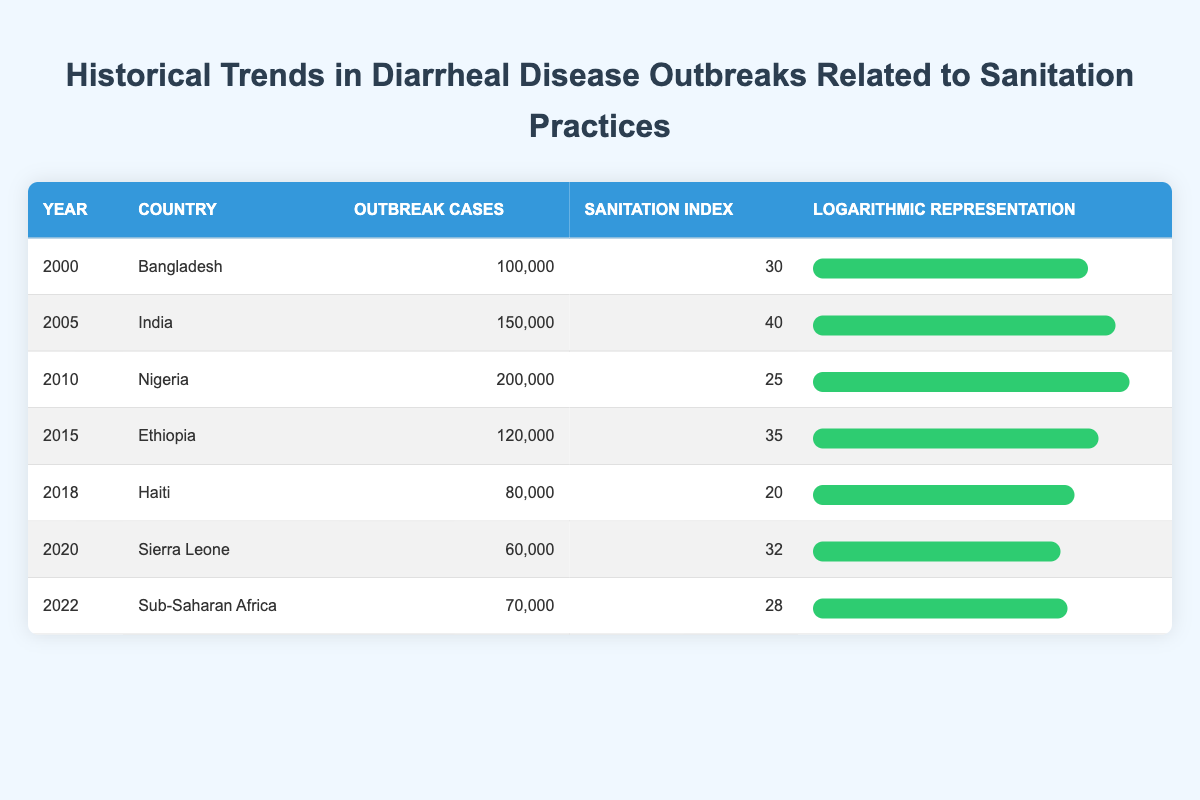What year had the highest number of outbreak cases? By looking at the "Outbreak Cases" column, I can determine the maximum value, which is 200,000 cases in the year 2010 for Nigeria.
Answer: 2010 What is the sanitation index for Ethiopia in 2015? The sanitation index for Ethiopia, listed in the table for the year 2015, is 35.
Answer: 35 Which country had a sanitation index of 40? Referring to the "Sanitation Index" column, I find that India had a sanitation index of 40 in the year 2005.
Answer: India Are there any years in the table where outbreak cases exceeded 100,000? I checked the "Outbreak Cases" column for values greater than 100,000. The years 2000, 2005, and 2010 exceed this threshold, confirming that yes, there are multiple years with outbreak cases above 100,000.
Answer: Yes What is the average number of outbreak cases across all listed years? To find the average, I sum all outbreak cases (100000 + 150000 + 200000 + 120000 + 80000 + 60000 + 70000 = 820000) and divide by the number of years, which is 7 (820000/7 = 117142.86). Rounding off, the average number of outbreak cases is approximately 117143.
Answer: 117143 Which country had the lowest sanitation index, and what was that index? The lowest sanitation index in the table is found under Haiti in 2018, which is 20. Thus, the country with the lowest sanitation index is Haiti.
Answer: Haiti, 20 Is it true that the number of outbreak cases decreased from 2010 to 2020? Comparing the outbreak cases from Nigeria in 2010 (200,000) and Sierra Leone in 2020 (60,000), there is a clear decrease in outbreak cases over this time period, confirming that this statement is true.
Answer: True If the sanitation index improved to 45, what impact might that have on outbreak cases based on historical trends? Historically, a higher sanitation index seems to correlate with lower outbreak cases. For example, India's sanitation index is 40 with 150,000 cases, whereas Nigeria with a lower sanitation index of 25 had 200,000 cases. Thus, if the index improved to 45, we could hypothesize that outbreak cases might decrease further compared to the current trends observed.
Answer: Outbreak cases might decrease 